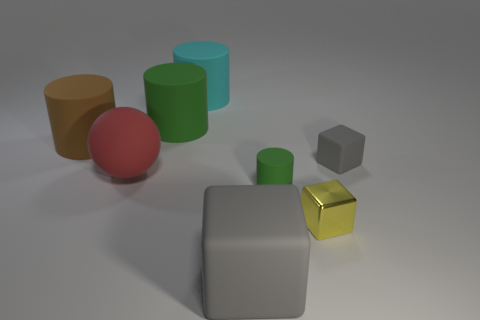Is there any other thing that is made of the same material as the small yellow cube?
Your answer should be very brief. No. Do the red rubber ball and the gray object that is left of the small yellow shiny object have the same size?
Your response must be concise. Yes. Is there another cylinder of the same color as the small matte cylinder?
Offer a very short reply. Yes. How many big objects are either yellow things or gray cylinders?
Give a very brief answer. 0. What number of big cubes are there?
Your answer should be very brief. 1. What is the green object behind the small green rubber thing made of?
Your response must be concise. Rubber. Are there any green objects in front of the tiny rubber cylinder?
Give a very brief answer. No. Do the red ball and the brown rubber thing have the same size?
Offer a very short reply. Yes. How many large cyan things are the same material as the small yellow cube?
Your answer should be very brief. 0. There is a thing behind the green rubber thing that is on the left side of the large cyan cylinder; what is its size?
Offer a very short reply. Large. 